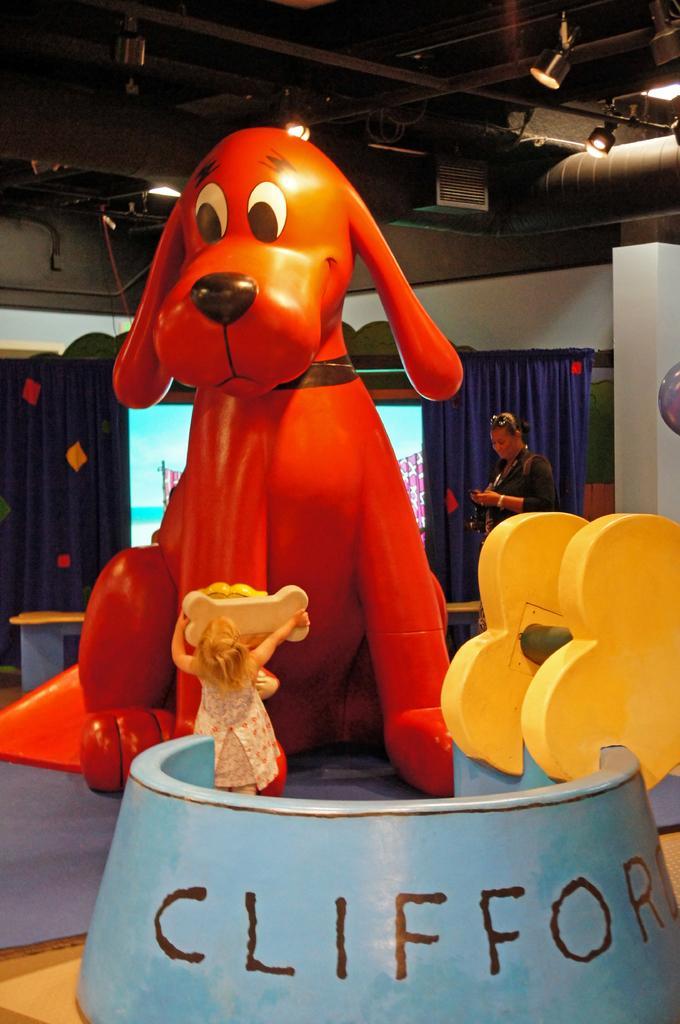Describe this image in one or two sentences. In this image we can see a child standing here and holding a toy bone in her hands. Here we can see a dog bowl and a red color big toy kept here. In the background, we can see a person standing here, we can see the curtains and the screen here and lights to the ceiling. 